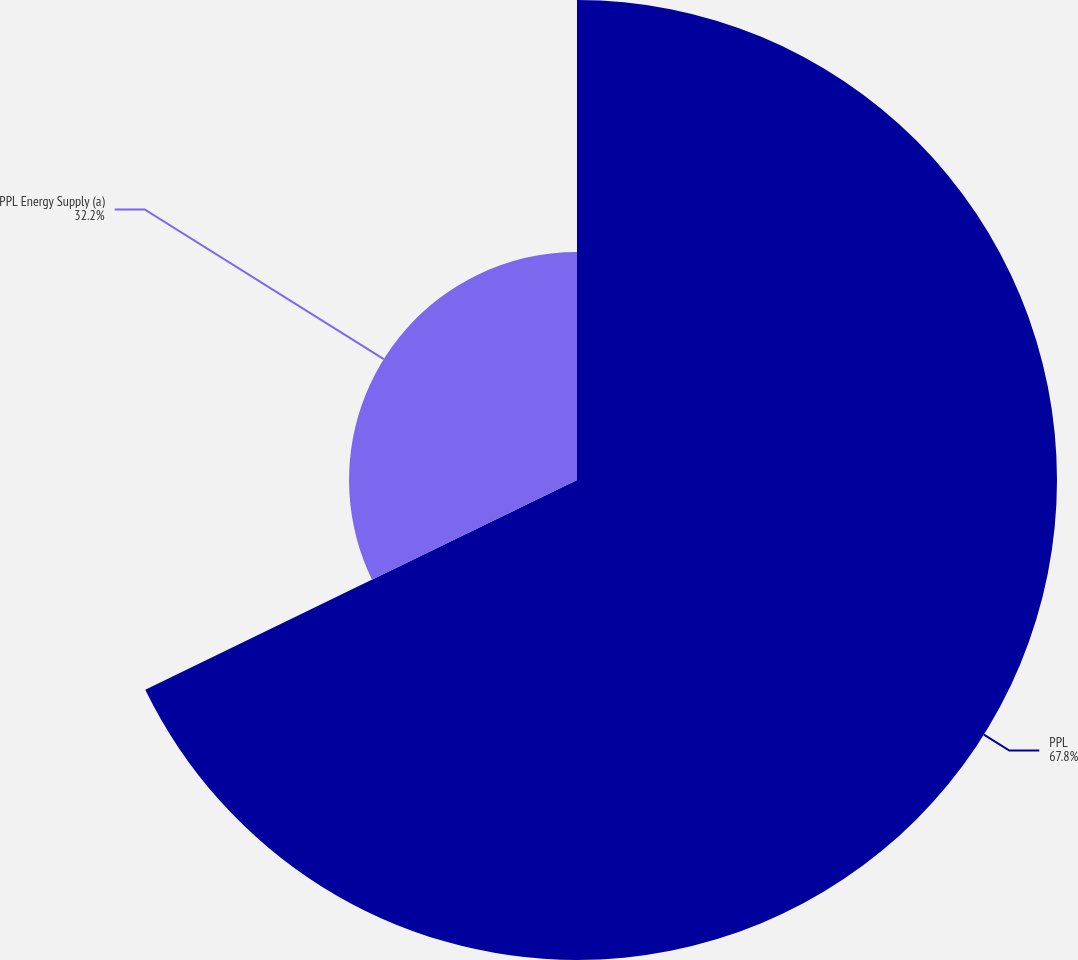Convert chart to OTSL. <chart><loc_0><loc_0><loc_500><loc_500><pie_chart><fcel>PPL<fcel>PPL Energy Supply (a)<nl><fcel>67.8%<fcel>32.2%<nl></chart> 